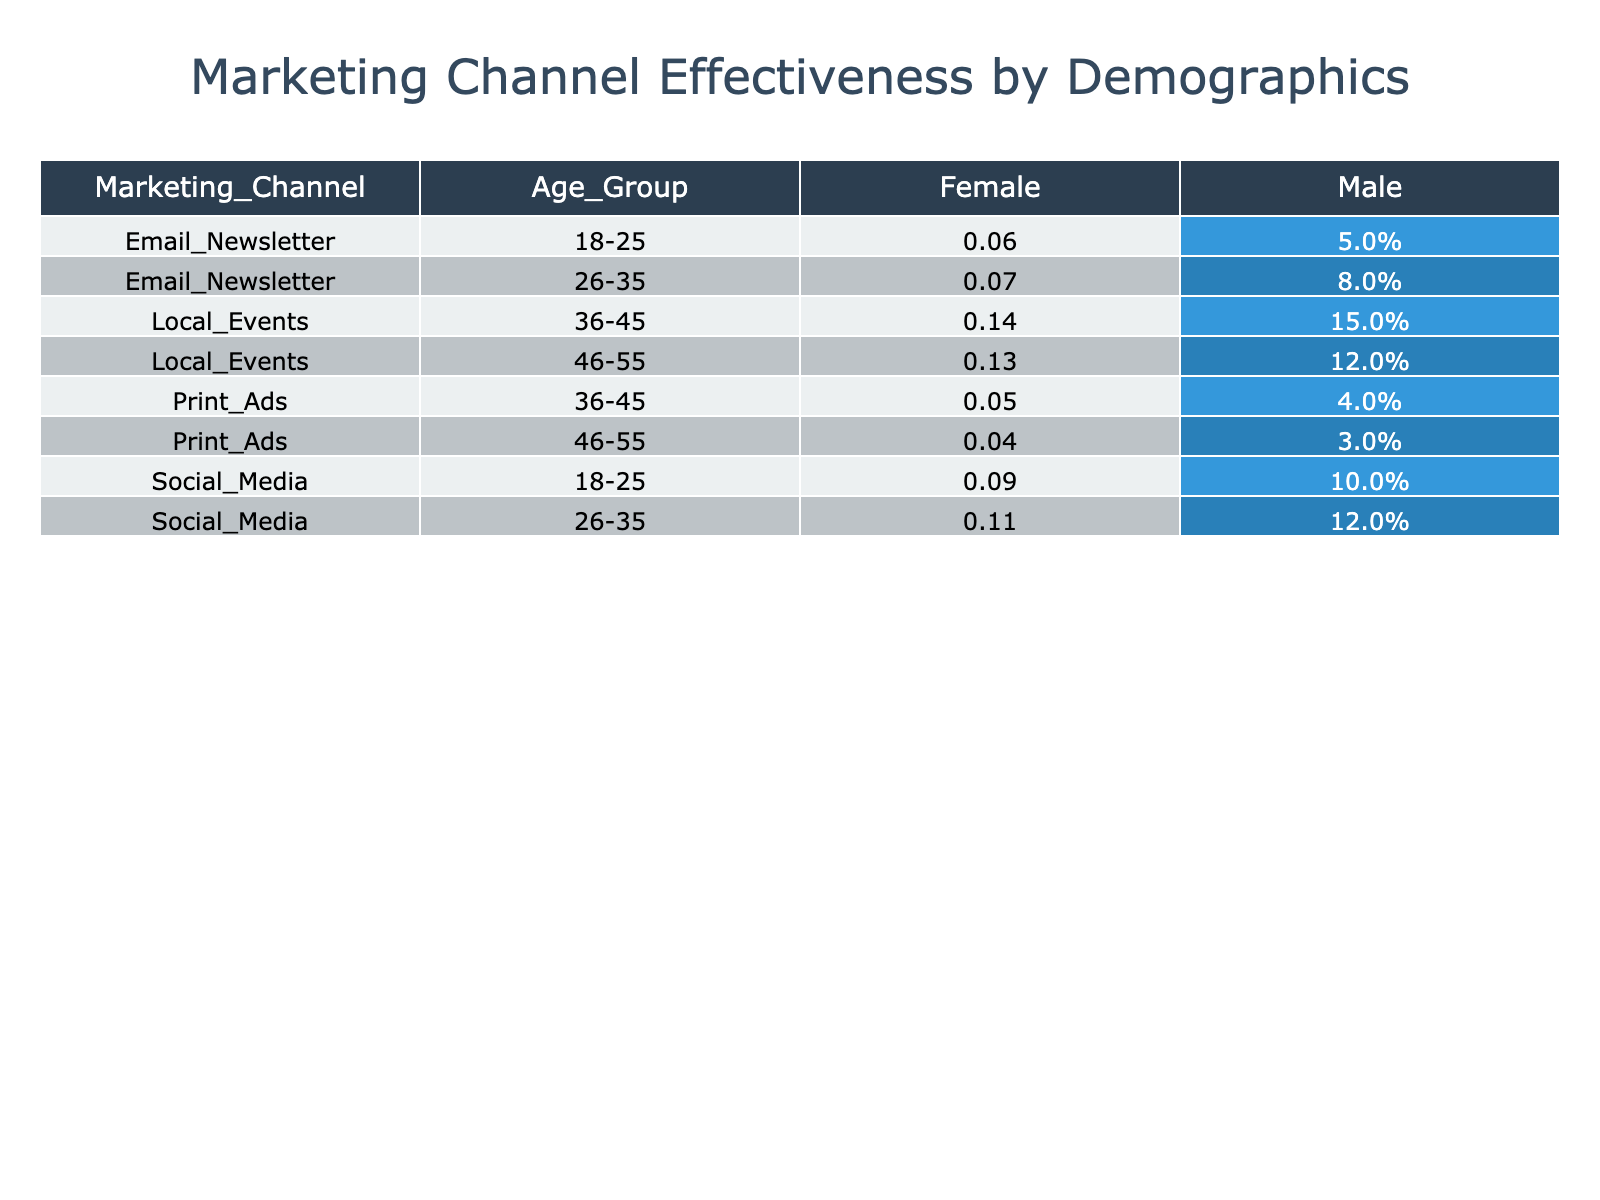What is the highest conversion rate for the Social Media marketing channel among all demographics? The Social Media marketing channel has four entries: (10%, 9%, 12%, and 11%). The highest value among these rates is 12% for the age group 26-35, male.
Answer: 12% Which age group has the best average conversion rate for Local Events? Local Events for the age groups 36-45 has conversion rates of 15% (Male) and 14% (Female) making an average of (15% + 14%) / 2 = 14.5%. The age group 46-55 has conversion rates of 12% (Male) and 13% (Female), giving an average of (12% + 13%) / 2 = 12.5%. Therefore, the 36-45 age group has the best average conversion rate of 14.5%.
Answer: 14.5% Is the overall conversion rate for Female demographic higher in Email Newsletter or Print Ads? The average conversion rate for Email Newsletter is (5% + 6% + 8% + 7%) / 4 = 6.5%. The average for Print Ads is (5% + 4%) / 2 = 4.5%. Since 6.5% is higher than 4.5%, the Female demographic has a higher conversion rate for Email Newsletter.
Answer: Yes What is the total reach from Social Media for the 18-25 age group across both genders? The reach for Social Media in the 18-25 age group is 1500 (Male) + 1800 (Female) = 3300.
Answer: 3300 What is the difference in conversion rates between Male and Female for the Local Events in the 36-45 age group? Local Events for age group 36-45 has a Male conversion rate of 15% and a Female conversion rate of 14%. The difference is 15% - 14% = 1%.
Answer: 1% Which marketing channel had the lowest engagement for the 46-55 age group? Looking at the 46-55 age group, the engagement rates are 300 (Male) for Local Events and 80 (Male) for Print Ads, while Female engagement is 350 (Local Events) and 90 (Print Ads). The lowest engagement overall is 80 for Print Ads.
Answer: Print Ads What percentage of the total reach is attributed to the Email Newsletter in the 26-35 age group? The reach for Email Newsletter in the 26-35 age group is 800 (Male) + 850 (Female) = 1650. The total reach across all marketing channels and age groups is 1500 + 1800 + 1200 + 1300 + 600 + 700 + 800 + 850 + 900 + 1100 + 700 + 800 = 11300. The percentage is (1650 / 11300) * 100 ≈ 14.6%.
Answer: 14.6% Do Local Events have a higher average engagement than Email Newsletters across all age groups? For Local Events, the total engagement is (400 + 450 + 300 + 350) = 1500 for all groups. For Email Newsletters, it is (150 + 200 + 200 + 230) = 780. Comparing the averages: Local Events average is 1500 / 4 = 375 and Email Newsletters average is 780 / 4 = 195. Since 375 is greater than 195, Local Events have a higher average engagement.
Answer: Yes 